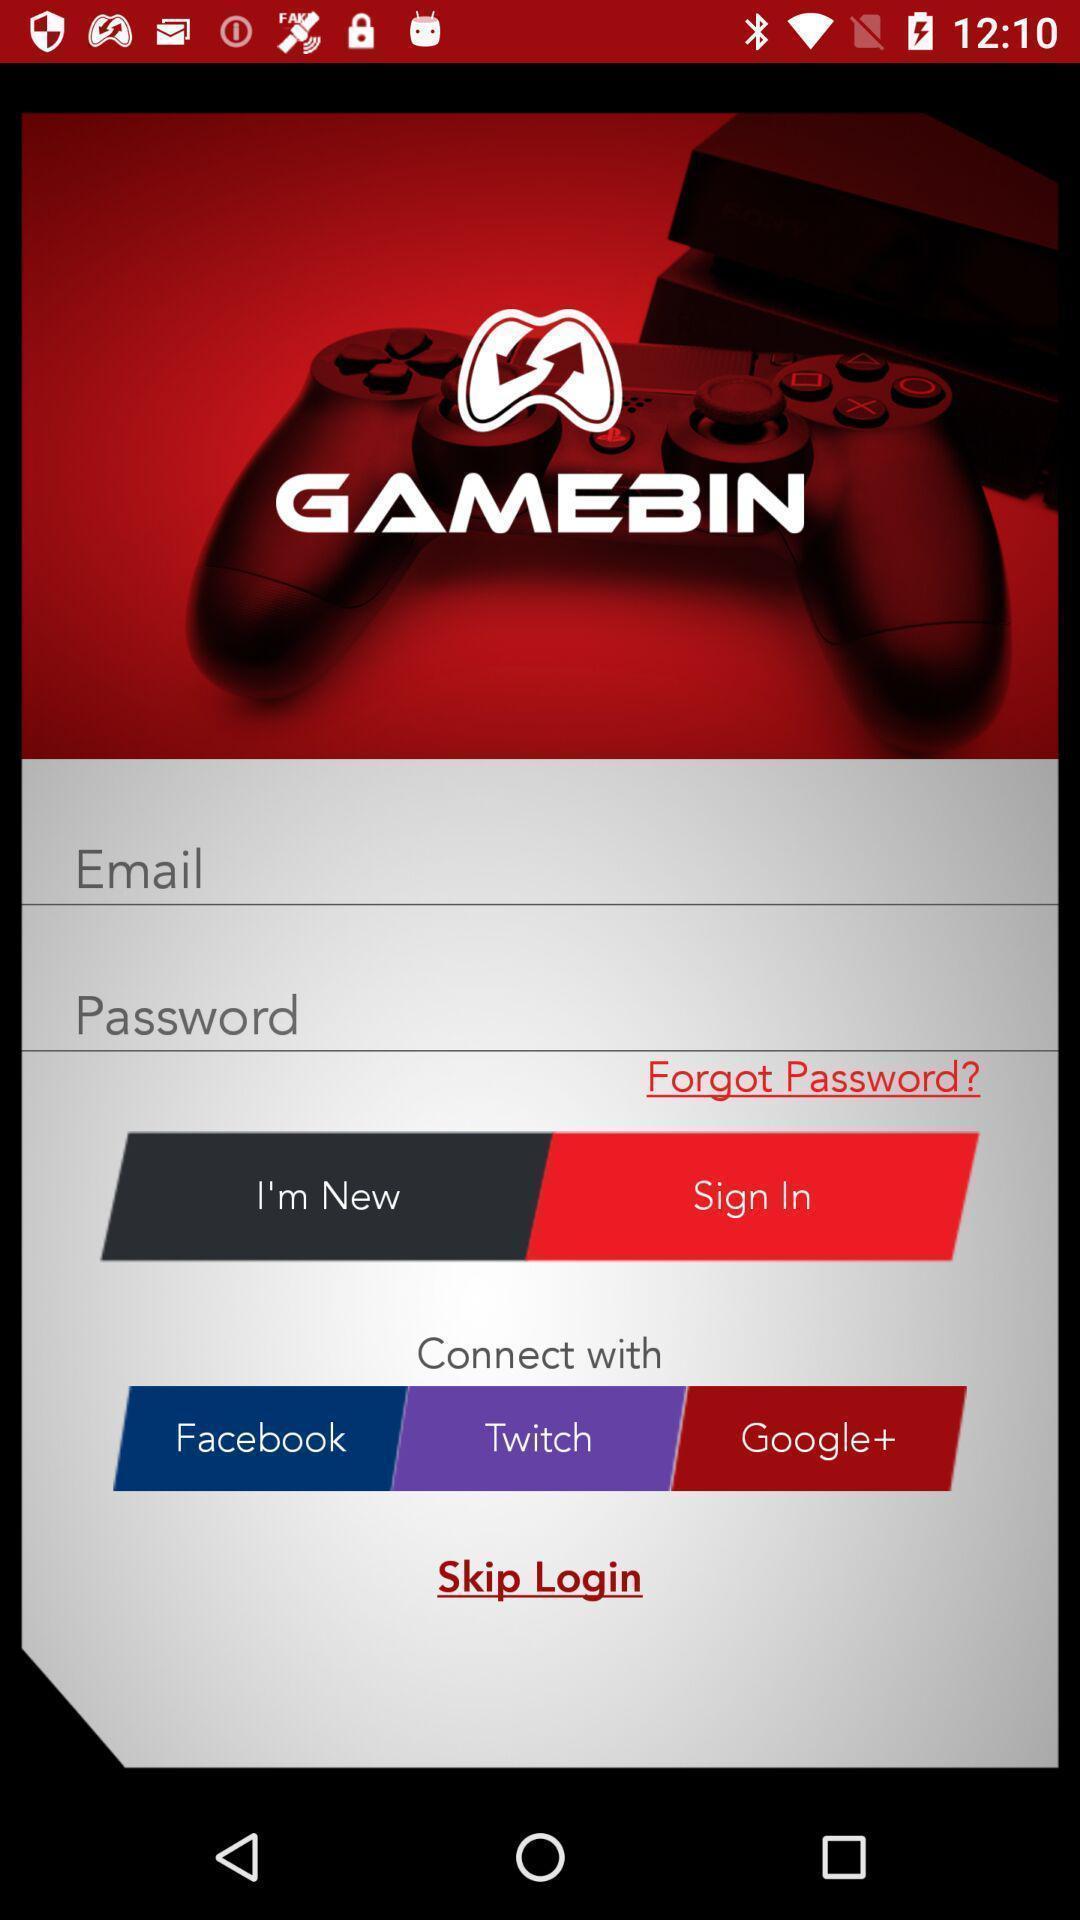Describe the content in this image. Sign in page. 